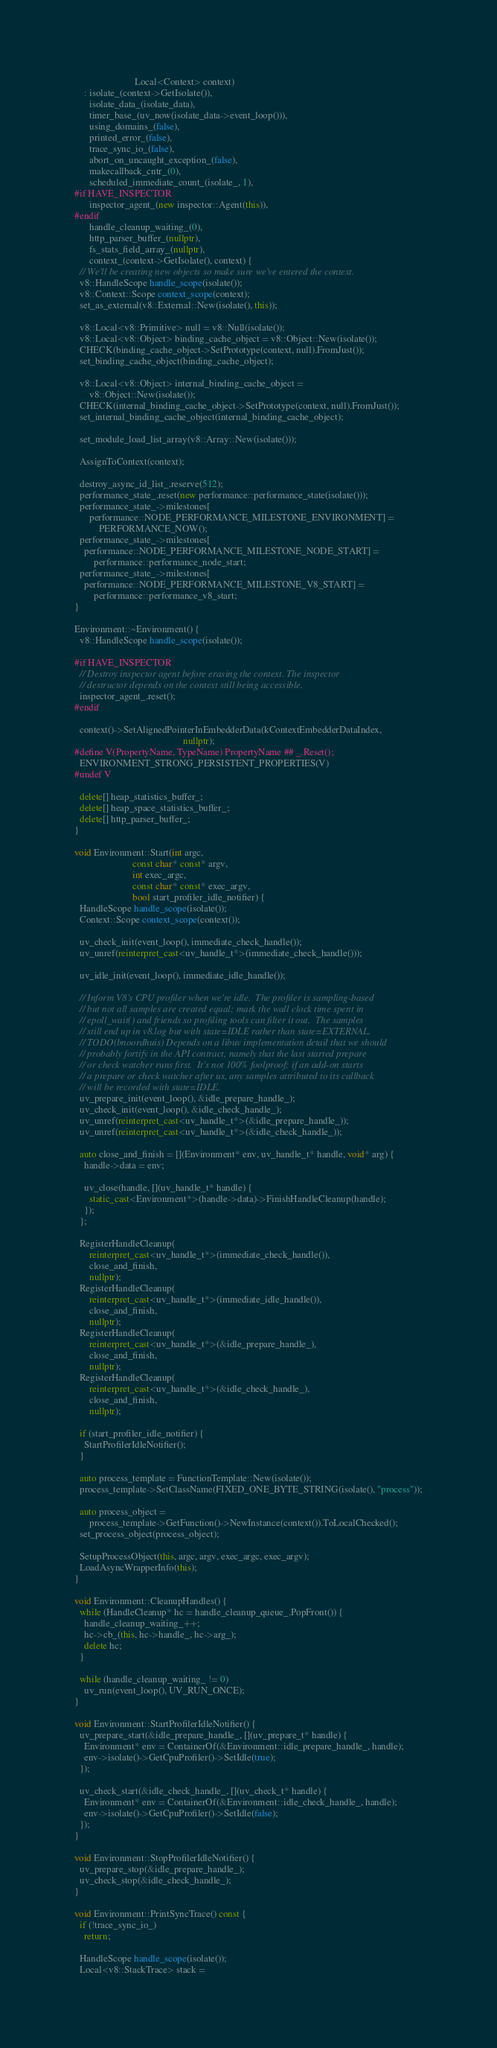<code> <loc_0><loc_0><loc_500><loc_500><_C++_>                         Local<Context> context)
    : isolate_(context->GetIsolate()),
      isolate_data_(isolate_data),
      timer_base_(uv_now(isolate_data->event_loop())),
      using_domains_(false),
      printed_error_(false),
      trace_sync_io_(false),
      abort_on_uncaught_exception_(false),
      makecallback_cntr_(0),
      scheduled_immediate_count_(isolate_, 1),
#if HAVE_INSPECTOR
      inspector_agent_(new inspector::Agent(this)),
#endif
      handle_cleanup_waiting_(0),
      http_parser_buffer_(nullptr),
      fs_stats_field_array_(nullptr),
      context_(context->GetIsolate(), context) {
  // We'll be creating new objects so make sure we've entered the context.
  v8::HandleScope handle_scope(isolate());
  v8::Context::Scope context_scope(context);
  set_as_external(v8::External::New(isolate(), this));

  v8::Local<v8::Primitive> null = v8::Null(isolate());
  v8::Local<v8::Object> binding_cache_object = v8::Object::New(isolate());
  CHECK(binding_cache_object->SetPrototype(context, null).FromJust());
  set_binding_cache_object(binding_cache_object);

  v8::Local<v8::Object> internal_binding_cache_object =
      v8::Object::New(isolate());
  CHECK(internal_binding_cache_object->SetPrototype(context, null).FromJust());
  set_internal_binding_cache_object(internal_binding_cache_object);

  set_module_load_list_array(v8::Array::New(isolate()));

  AssignToContext(context);

  destroy_async_id_list_.reserve(512);
  performance_state_.reset(new performance::performance_state(isolate()));
  performance_state_->milestones[
      performance::NODE_PERFORMANCE_MILESTONE_ENVIRONMENT] =
          PERFORMANCE_NOW();
  performance_state_->milestones[
    performance::NODE_PERFORMANCE_MILESTONE_NODE_START] =
        performance::performance_node_start;
  performance_state_->milestones[
    performance::NODE_PERFORMANCE_MILESTONE_V8_START] =
        performance::performance_v8_start;
}

Environment::~Environment() {
  v8::HandleScope handle_scope(isolate());

#if HAVE_INSPECTOR
  // Destroy inspector agent before erasing the context. The inspector
  // destructor depends on the context still being accessible.
  inspector_agent_.reset();
#endif

  context()->SetAlignedPointerInEmbedderData(kContextEmbedderDataIndex,
                                             nullptr);
#define V(PropertyName, TypeName) PropertyName ## _.Reset();
  ENVIRONMENT_STRONG_PERSISTENT_PROPERTIES(V)
#undef V

  delete[] heap_statistics_buffer_;
  delete[] heap_space_statistics_buffer_;
  delete[] http_parser_buffer_;
}

void Environment::Start(int argc,
                        const char* const* argv,
                        int exec_argc,
                        const char* const* exec_argv,
                        bool start_profiler_idle_notifier) {
  HandleScope handle_scope(isolate());
  Context::Scope context_scope(context());

  uv_check_init(event_loop(), immediate_check_handle());
  uv_unref(reinterpret_cast<uv_handle_t*>(immediate_check_handle()));

  uv_idle_init(event_loop(), immediate_idle_handle());

  // Inform V8's CPU profiler when we're idle.  The profiler is sampling-based
  // but not all samples are created equal; mark the wall clock time spent in
  // epoll_wait() and friends so profiling tools can filter it out.  The samples
  // still end up in v8.log but with state=IDLE rather than state=EXTERNAL.
  // TODO(bnoordhuis) Depends on a libuv implementation detail that we should
  // probably fortify in the API contract, namely that the last started prepare
  // or check watcher runs first.  It's not 100% foolproof; if an add-on starts
  // a prepare or check watcher after us, any samples attributed to its callback
  // will be recorded with state=IDLE.
  uv_prepare_init(event_loop(), &idle_prepare_handle_);
  uv_check_init(event_loop(), &idle_check_handle_);
  uv_unref(reinterpret_cast<uv_handle_t*>(&idle_prepare_handle_));
  uv_unref(reinterpret_cast<uv_handle_t*>(&idle_check_handle_));

  auto close_and_finish = [](Environment* env, uv_handle_t* handle, void* arg) {
    handle->data = env;

    uv_close(handle, [](uv_handle_t* handle) {
      static_cast<Environment*>(handle->data)->FinishHandleCleanup(handle);
    });
  };

  RegisterHandleCleanup(
      reinterpret_cast<uv_handle_t*>(immediate_check_handle()),
      close_and_finish,
      nullptr);
  RegisterHandleCleanup(
      reinterpret_cast<uv_handle_t*>(immediate_idle_handle()),
      close_and_finish,
      nullptr);
  RegisterHandleCleanup(
      reinterpret_cast<uv_handle_t*>(&idle_prepare_handle_),
      close_and_finish,
      nullptr);
  RegisterHandleCleanup(
      reinterpret_cast<uv_handle_t*>(&idle_check_handle_),
      close_and_finish,
      nullptr);

  if (start_profiler_idle_notifier) {
    StartProfilerIdleNotifier();
  }

  auto process_template = FunctionTemplate::New(isolate());
  process_template->SetClassName(FIXED_ONE_BYTE_STRING(isolate(), "process"));

  auto process_object =
      process_template->GetFunction()->NewInstance(context()).ToLocalChecked();
  set_process_object(process_object);

  SetupProcessObject(this, argc, argv, exec_argc, exec_argv);
  LoadAsyncWrapperInfo(this);
}

void Environment::CleanupHandles() {
  while (HandleCleanup* hc = handle_cleanup_queue_.PopFront()) {
    handle_cleanup_waiting_++;
    hc->cb_(this, hc->handle_, hc->arg_);
    delete hc;
  }

  while (handle_cleanup_waiting_ != 0)
    uv_run(event_loop(), UV_RUN_ONCE);
}

void Environment::StartProfilerIdleNotifier() {
  uv_prepare_start(&idle_prepare_handle_, [](uv_prepare_t* handle) {
    Environment* env = ContainerOf(&Environment::idle_prepare_handle_, handle);
    env->isolate()->GetCpuProfiler()->SetIdle(true);
  });

  uv_check_start(&idle_check_handle_, [](uv_check_t* handle) {
    Environment* env = ContainerOf(&Environment::idle_check_handle_, handle);
    env->isolate()->GetCpuProfiler()->SetIdle(false);
  });
}

void Environment::StopProfilerIdleNotifier() {
  uv_prepare_stop(&idle_prepare_handle_);
  uv_check_stop(&idle_check_handle_);
}

void Environment::PrintSyncTrace() const {
  if (!trace_sync_io_)
    return;

  HandleScope handle_scope(isolate());
  Local<v8::StackTrace> stack =</code> 